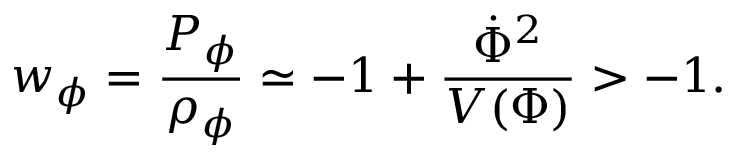<formula> <loc_0><loc_0><loc_500><loc_500>w _ { \phi } = \frac { P _ { \phi } } { \rho _ { \phi } } \simeq - 1 + \frac { \dot { \Phi } ^ { 2 } } { V ( \Phi ) } > - 1 .</formula> 